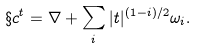Convert formula to latex. <formula><loc_0><loc_0><loc_500><loc_500>\S c ^ { t } = \nabla + \sum _ { i } | t | ^ { ( 1 - i ) / 2 } \omega _ { i } .</formula> 